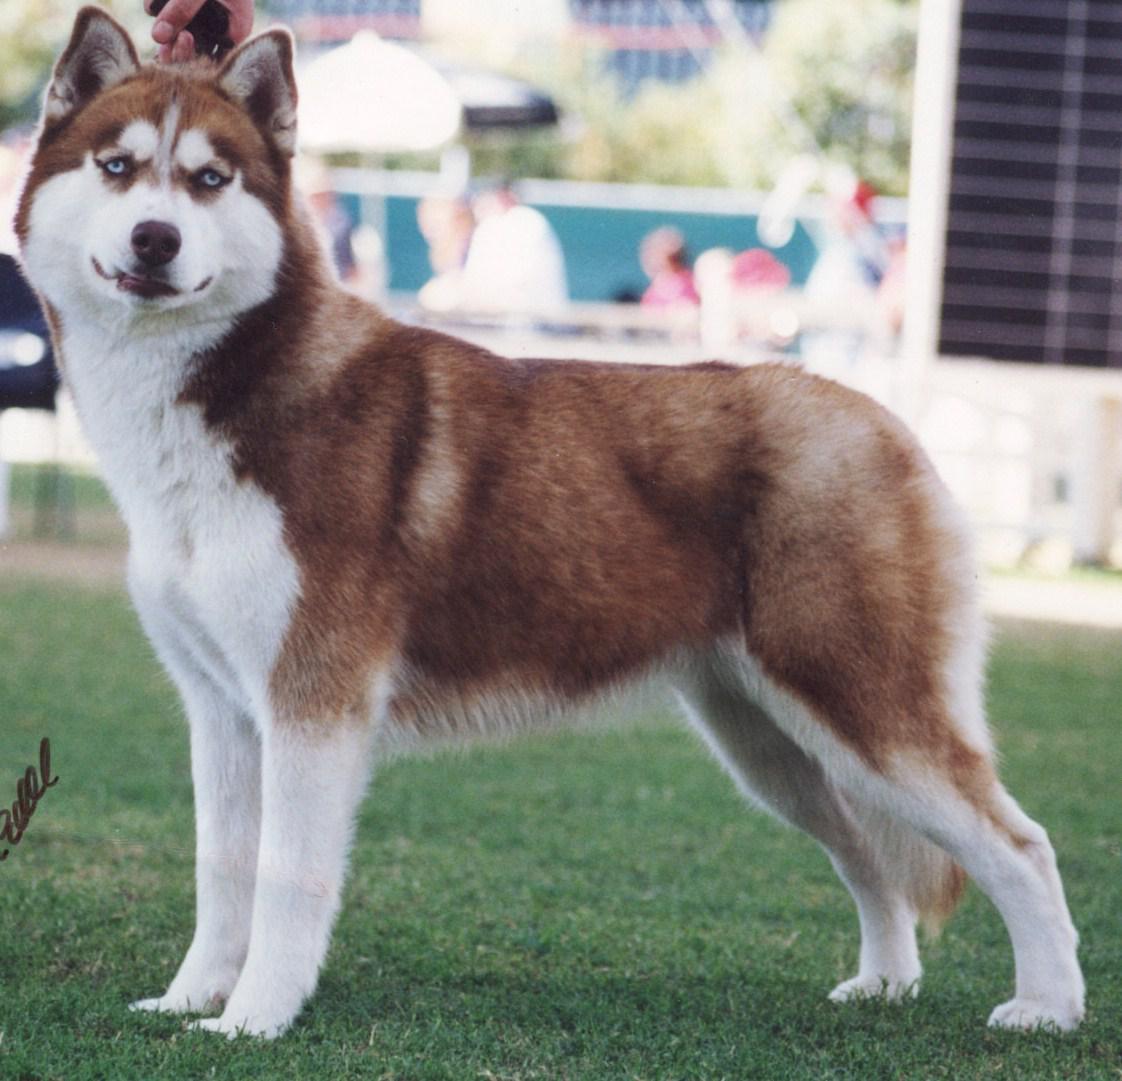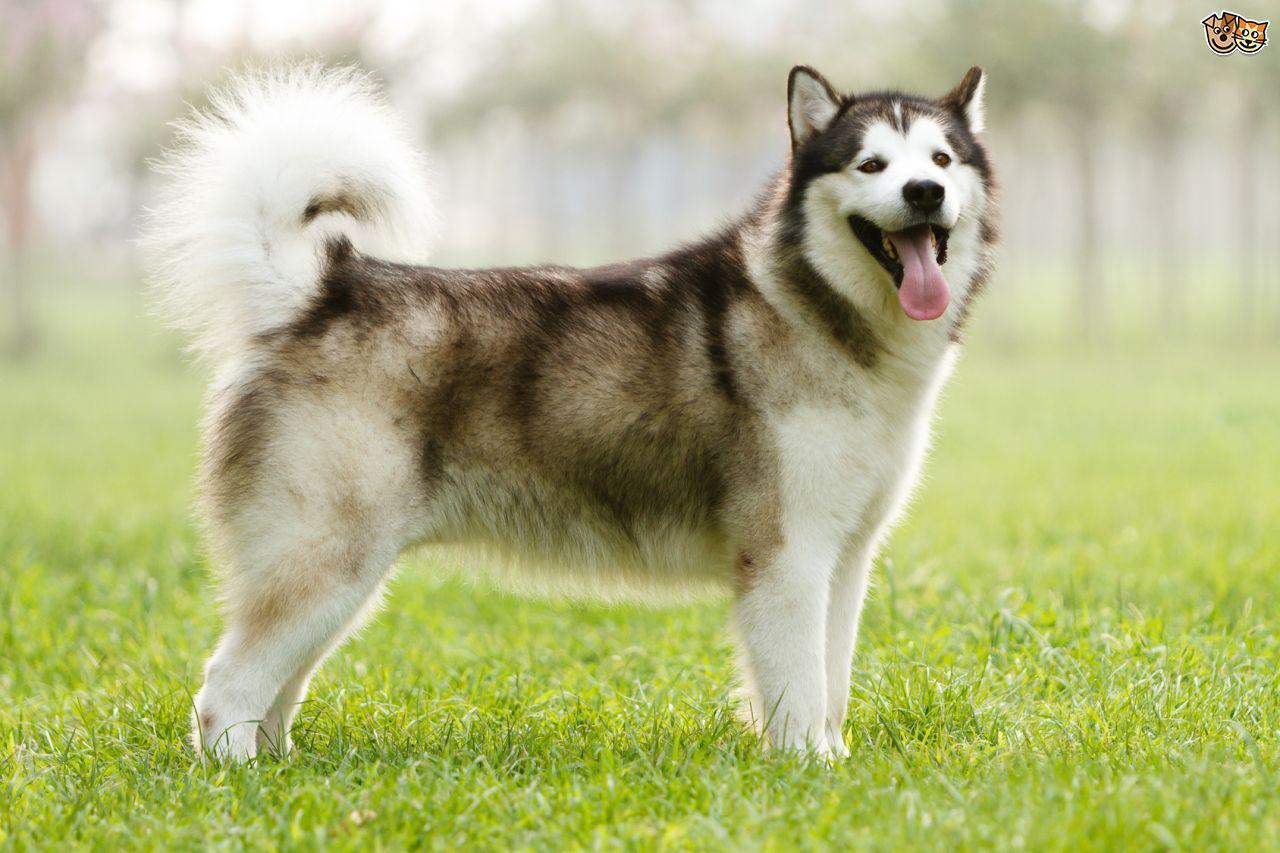The first image is the image on the left, the second image is the image on the right. Evaluate the accuracy of this statement regarding the images: "The right image contains one dog standing on green grass.". Is it true? Answer yes or no. Yes. The first image is the image on the left, the second image is the image on the right. Considering the images on both sides, is "All dogs are standing with bodies in profile, at least one with its tail curled inward toward its back, and the dogs in the left and right images gaze in the same direction." valid? Answer yes or no. Yes. 